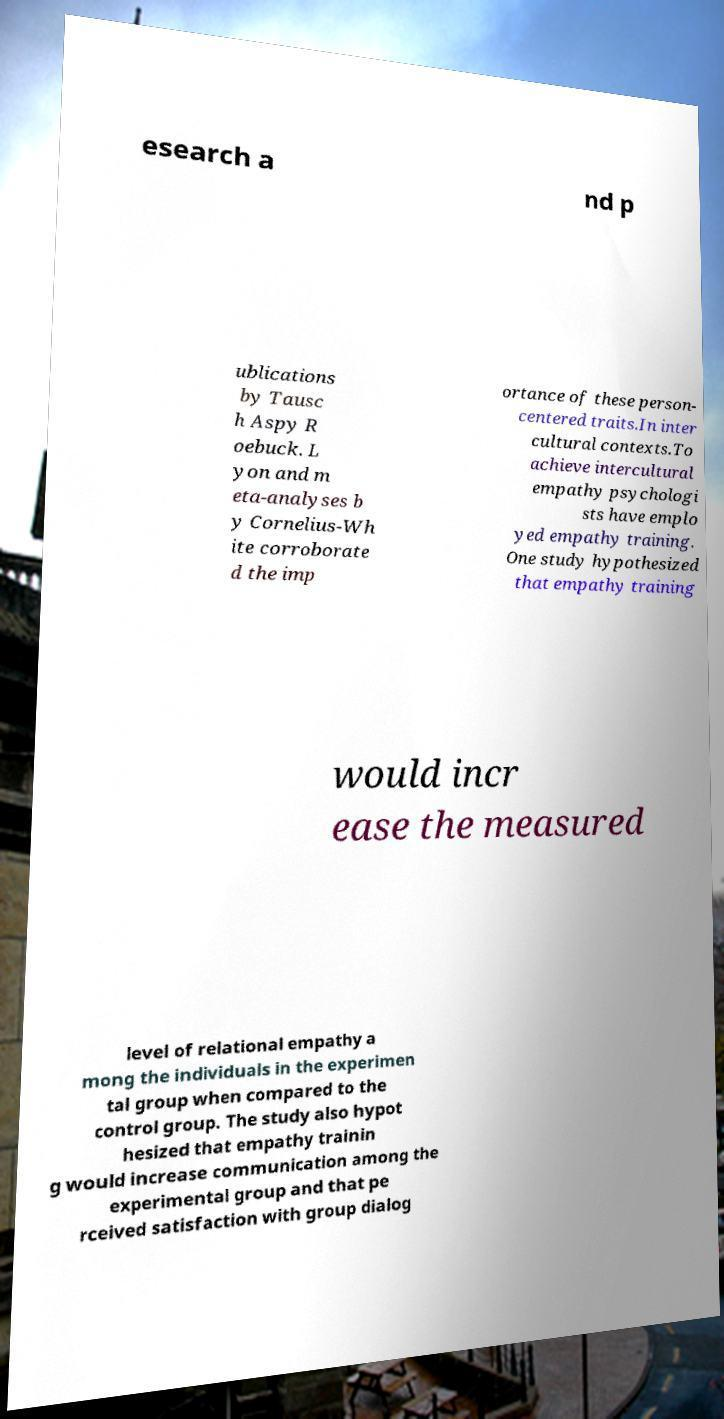Please read and relay the text visible in this image. What does it say? esearch a nd p ublications by Tausc h Aspy R oebuck. L yon and m eta-analyses b y Cornelius-Wh ite corroborate d the imp ortance of these person- centered traits.In inter cultural contexts.To achieve intercultural empathy psychologi sts have emplo yed empathy training. One study hypothesized that empathy training would incr ease the measured level of relational empathy a mong the individuals in the experimen tal group when compared to the control group. The study also hypot hesized that empathy trainin g would increase communication among the experimental group and that pe rceived satisfaction with group dialog 